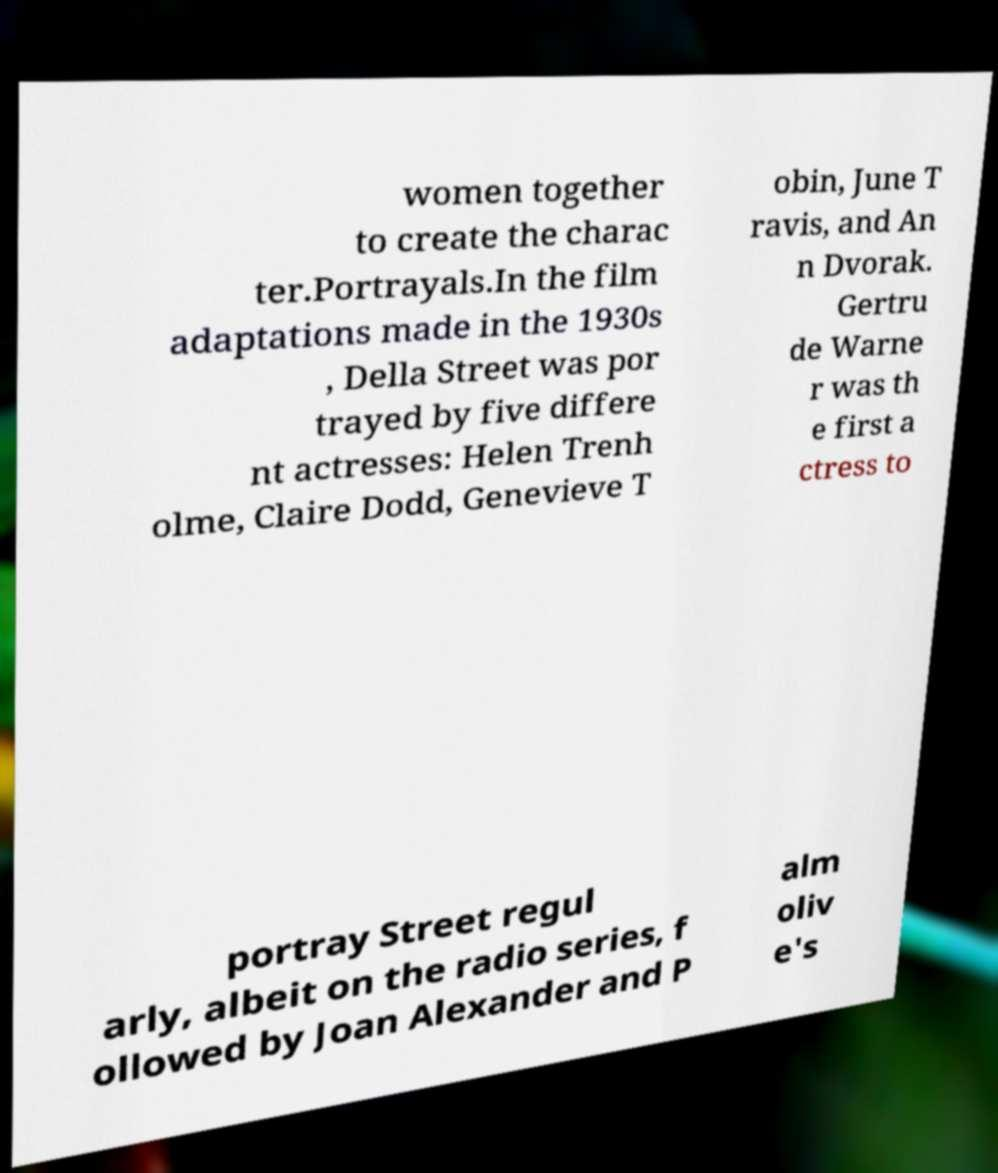I need the written content from this picture converted into text. Can you do that? women together to create the charac ter.Portrayals.In the film adaptations made in the 1930s , Della Street was por trayed by five differe nt actresses: Helen Trenh olme, Claire Dodd, Genevieve T obin, June T ravis, and An n Dvorak. Gertru de Warne r was th e first a ctress to portray Street regul arly, albeit on the radio series, f ollowed by Joan Alexander and P alm oliv e's 